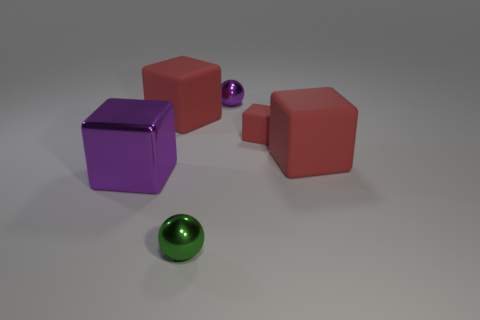What size is the red block on the right side of the small matte block?
Offer a very short reply. Large. Are there the same number of purple cubes that are in front of the big purple cube and tiny metallic spheres that are on the left side of the small purple sphere?
Your answer should be very brief. No. What color is the tiny thing that is in front of the big red matte object right of the large red rubber thing that is to the left of the tiny purple ball?
Keep it short and to the point. Green. How many cubes are both behind the shiny cube and on the left side of the small green metal thing?
Keep it short and to the point. 1. There is a rubber object that is on the right side of the small red rubber thing; is its color the same as the shiny ball in front of the purple metallic ball?
Make the answer very short. No. Are there any other things that are the same material as the small green ball?
Your response must be concise. Yes. What is the size of the shiny object that is the same shape as the tiny red rubber thing?
Your answer should be very brief. Large. There is a small green metallic sphere; are there any matte cubes in front of it?
Offer a very short reply. No. Is the number of shiny cubes on the right side of the green thing the same as the number of red objects?
Keep it short and to the point. No. There is a big rubber block right of the tiny ball left of the purple ball; is there a small red matte cube to the right of it?
Provide a short and direct response. No. 